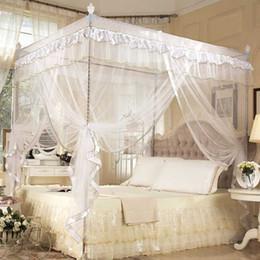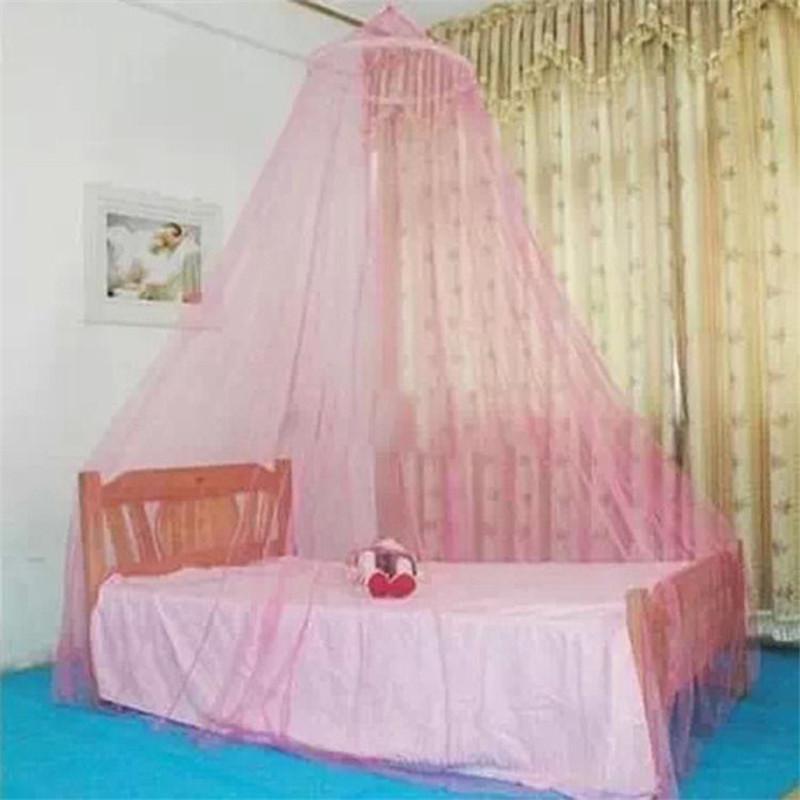The first image is the image on the left, the second image is the image on the right. Assess this claim about the two images: "The left and right image contains the same number of canopies one square and one circle.". Correct or not? Answer yes or no. Yes. 